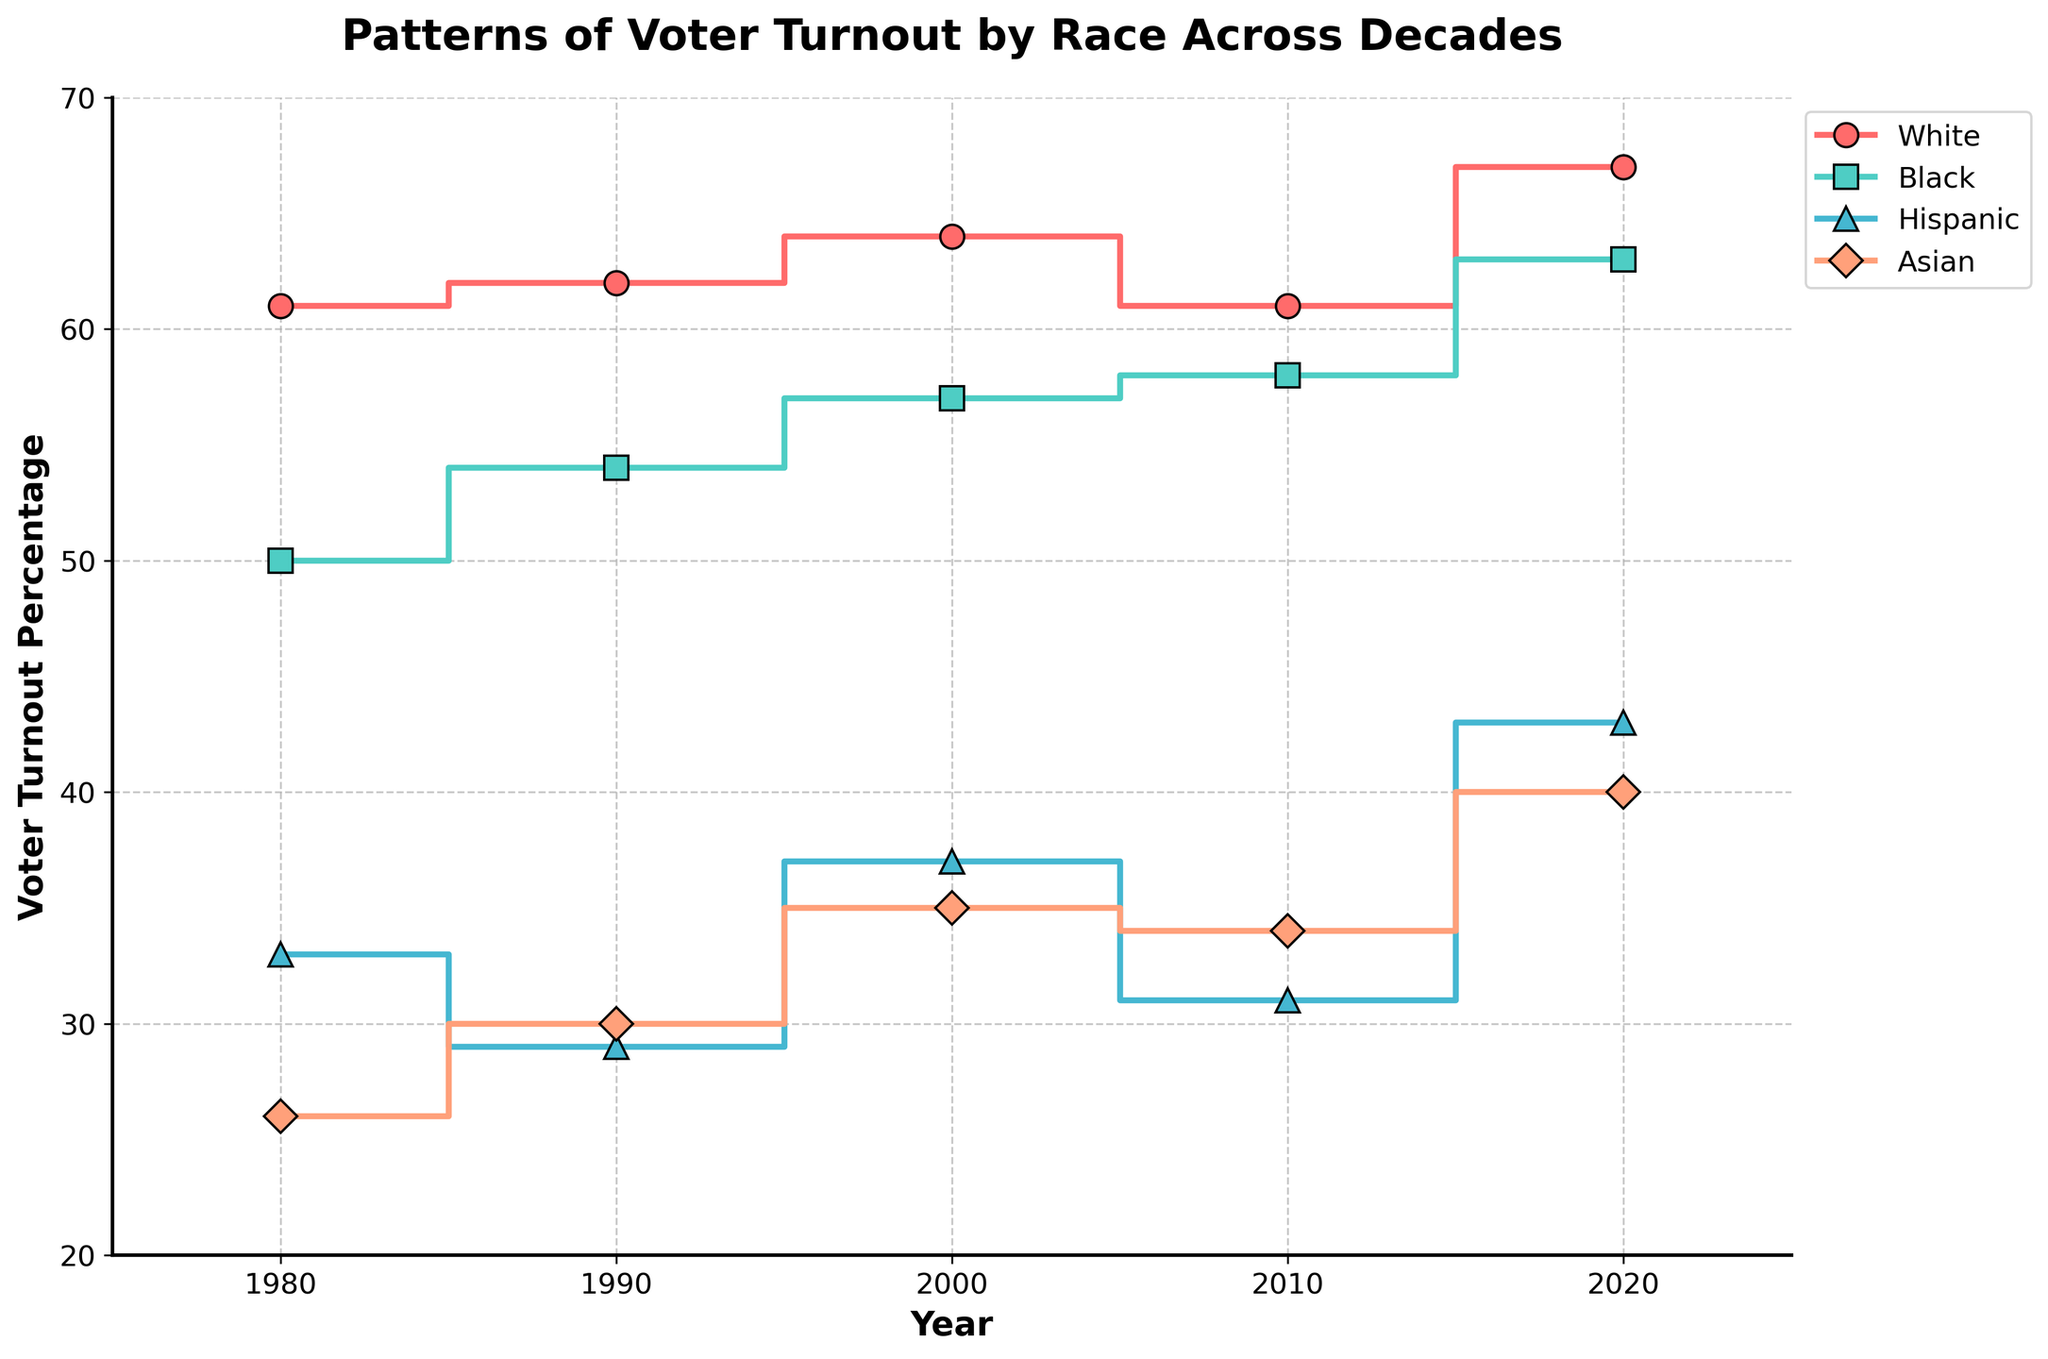what is the title of the plot? The title is usually displayed at the top of the figure. In this case, it is "Patterns of Voter Turnout by Race Across Decades."
Answer: Patterns of Voter Turnout by Race Across Decades What does the x-axis represent? The x-axis typically represents the variable being measured over time. In this figure, it represents the years.
Answer: Year How many distinct racial groups are represented in the plot? We can see that there are four steps or lines, each representing a racial group. By checking the legend, we see "White," "Black," "Hispanic," and "Asian."
Answer: 4 Which racial group had the highest voter turnout percentage in 2020? By looking at the endpoints of lines near the year 2020 on the x-axis, we can identify that the "White" group has the highest percentage among all groups in 2020.
Answer: White Has the voter turnout among the Hispanic population ever surpassed that of the Black population? We need to examine the stair steps (lines) for "Hispanic" and "Black" groups across all years. The "Black" line is always higher than the "Hispanic" line, indicating the former has had higher turnout in all observed years.
Answer: No Between which consecutive decades was there the largest increase in voter turnout for the Asian population? We observe the steps (vertical jumps) for the "Asian" group between 1980 to 1990, 1990 to 2000, 2000 to 2010, and 2010 to 2020. The most significant increase occurs between 2000 (35%) and 2020 (40%), an increase of 5 percentage points.
Answer: 2000 to 2020 What is the difference in voter turnout between the White and Hispanic populations in 1980? Locate the points for "White" and "Hispanic" in 1980. The "White" turnout is 61% and the "Hispanic" turnout is 33%. The difference is 61% - 33% = 28%.
Answer: 28% Calculate the average voter turnout for the Black population across all decades. Collect the turnout percentages for the Black population for all years: 1980 (50%), 1990 (54%), 2000 (57%), 2010 (58%), and 2020 (63%). Sum them and divide by the number of decades: (50 + 54 + 57 + 58 + 63) / 5 = 56.4%.
Answer: 56.4% Which racial group shows the most consistent turnout trends across the decades? Consistency can be observed by examining the steadiness of the stair steps. Both the "White" and "Asian" groups’ trends show fewer dramatic changes compared to others, but "White" exhibits the most consistent percentages, staying in a close range (61-67%).
Answer: White Did the voter turnout for the Black population ever equal or surpass that of the White population in any decade? By comparing the lines for "Black" and "White" groups across all years, you can see that the "Black" turnout approaches but never surpasses or equals the "White" turnout in any given year.
Answer: No 